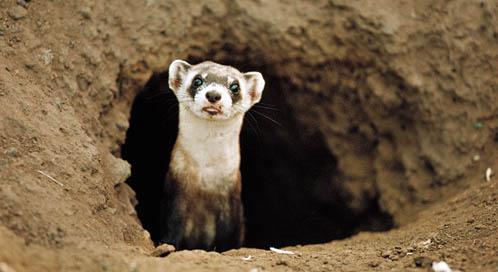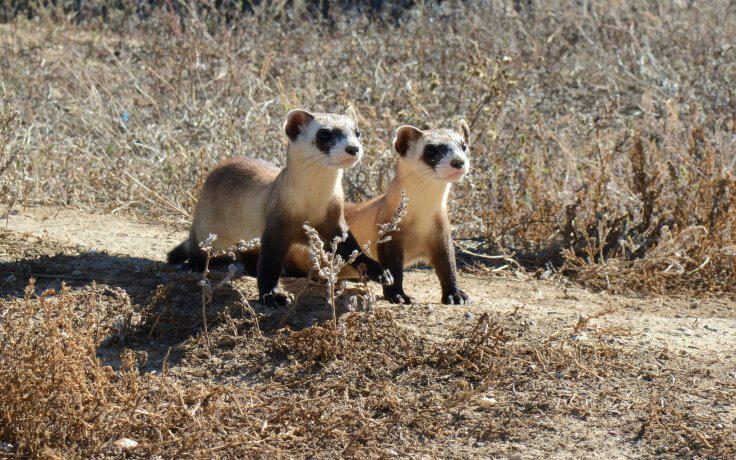The first image is the image on the left, the second image is the image on the right. Analyze the images presented: Is the assertion "There are 3 total ferrets." valid? Answer yes or no. Yes. The first image is the image on the left, the second image is the image on the right. Evaluate the accuracy of this statement regarding the images: "There are two ferrets total.". Is it true? Answer yes or no. No. 